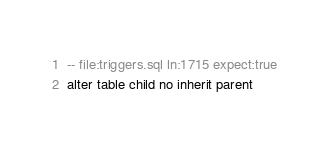Convert code to text. <code><loc_0><loc_0><loc_500><loc_500><_SQL_>-- file:triggers.sql ln:1715 expect:true
alter table child no inherit parent
</code> 